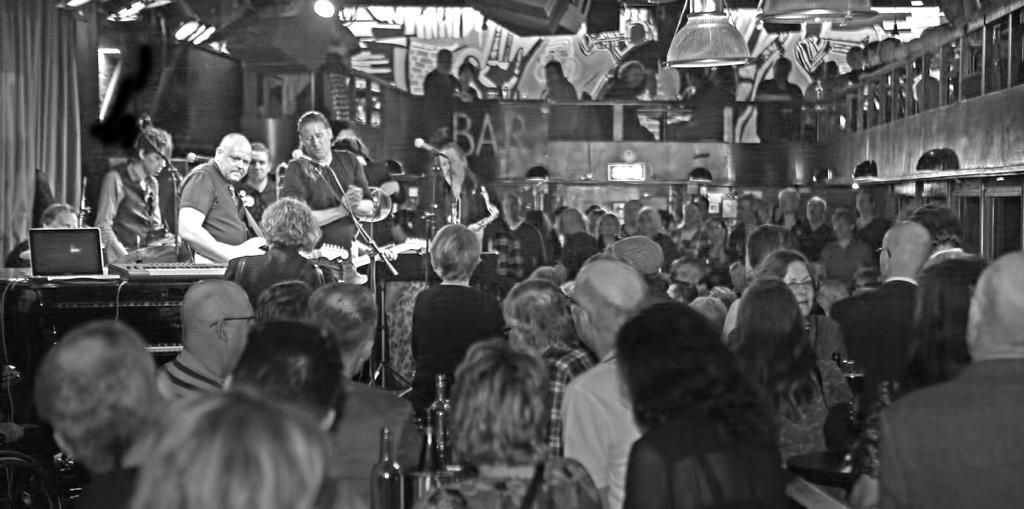Describe this image in one or two sentences. This is a black and white picture. We can see there are groups of people, bottles and a table. There are some people standing and holding the musical instruments. On the stage there are microphones with stands and some music systems. On the left side of the image there is a curtain. At the top there are lights. 